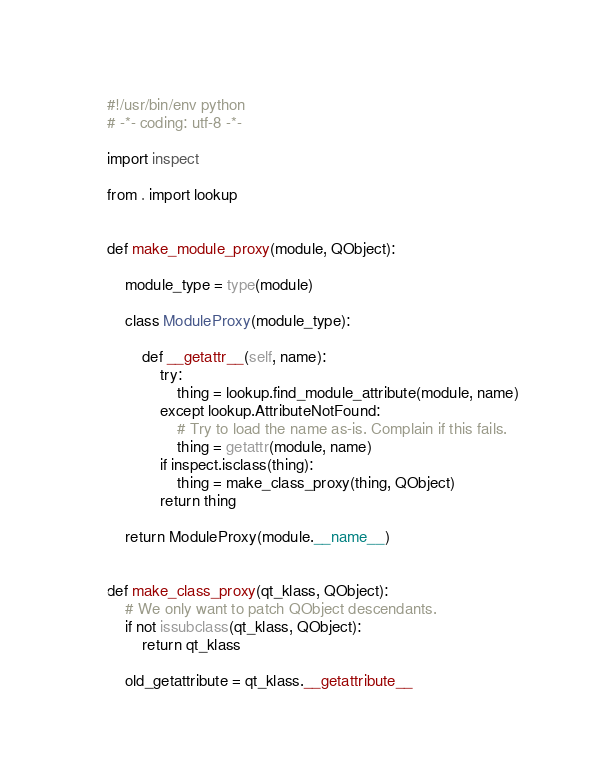Convert code to text. <code><loc_0><loc_0><loc_500><loc_500><_Python_>#!/usr/bin/env python
# -*- coding: utf-8 -*-

import inspect

from . import lookup


def make_module_proxy(module, QObject):

    module_type = type(module)

    class ModuleProxy(module_type):

        def __getattr__(self, name):
            try:
                thing = lookup.find_module_attribute(module, name)
            except lookup.AttributeNotFound:
                # Try to load the name as-is. Complain if this fails.
                thing = getattr(module, name)
            if inspect.isclass(thing):
                thing = make_class_proxy(thing, QObject)
            return thing

    return ModuleProxy(module.__name__)


def make_class_proxy(qt_klass, QObject):
    # We only want to patch QObject descendants.
    if not issubclass(qt_klass, QObject):
        return qt_klass

    old_getattribute = qt_klass.__getattribute__
</code> 